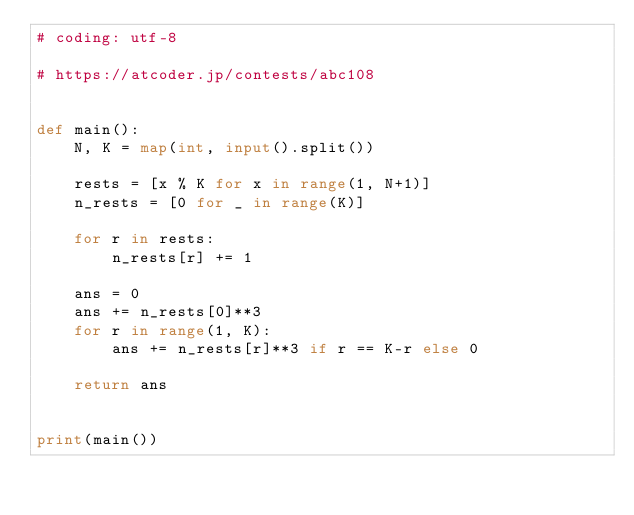<code> <loc_0><loc_0><loc_500><loc_500><_Python_># coding: utf-8

# https://atcoder.jp/contests/abc108


def main():
    N, K = map(int, input().split())

    rests = [x % K for x in range(1, N+1)]
    n_rests = [0 for _ in range(K)]
    
    for r in rests:
        n_rests[r] += 1
    
    ans = 0
    ans += n_rests[0]**3
    for r in range(1, K):
        ans += n_rests[r]**3 if r == K-r else 0
    
    return ans


print(main())
</code> 